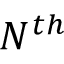Convert formula to latex. <formula><loc_0><loc_0><loc_500><loc_500>N ^ { t h }</formula> 